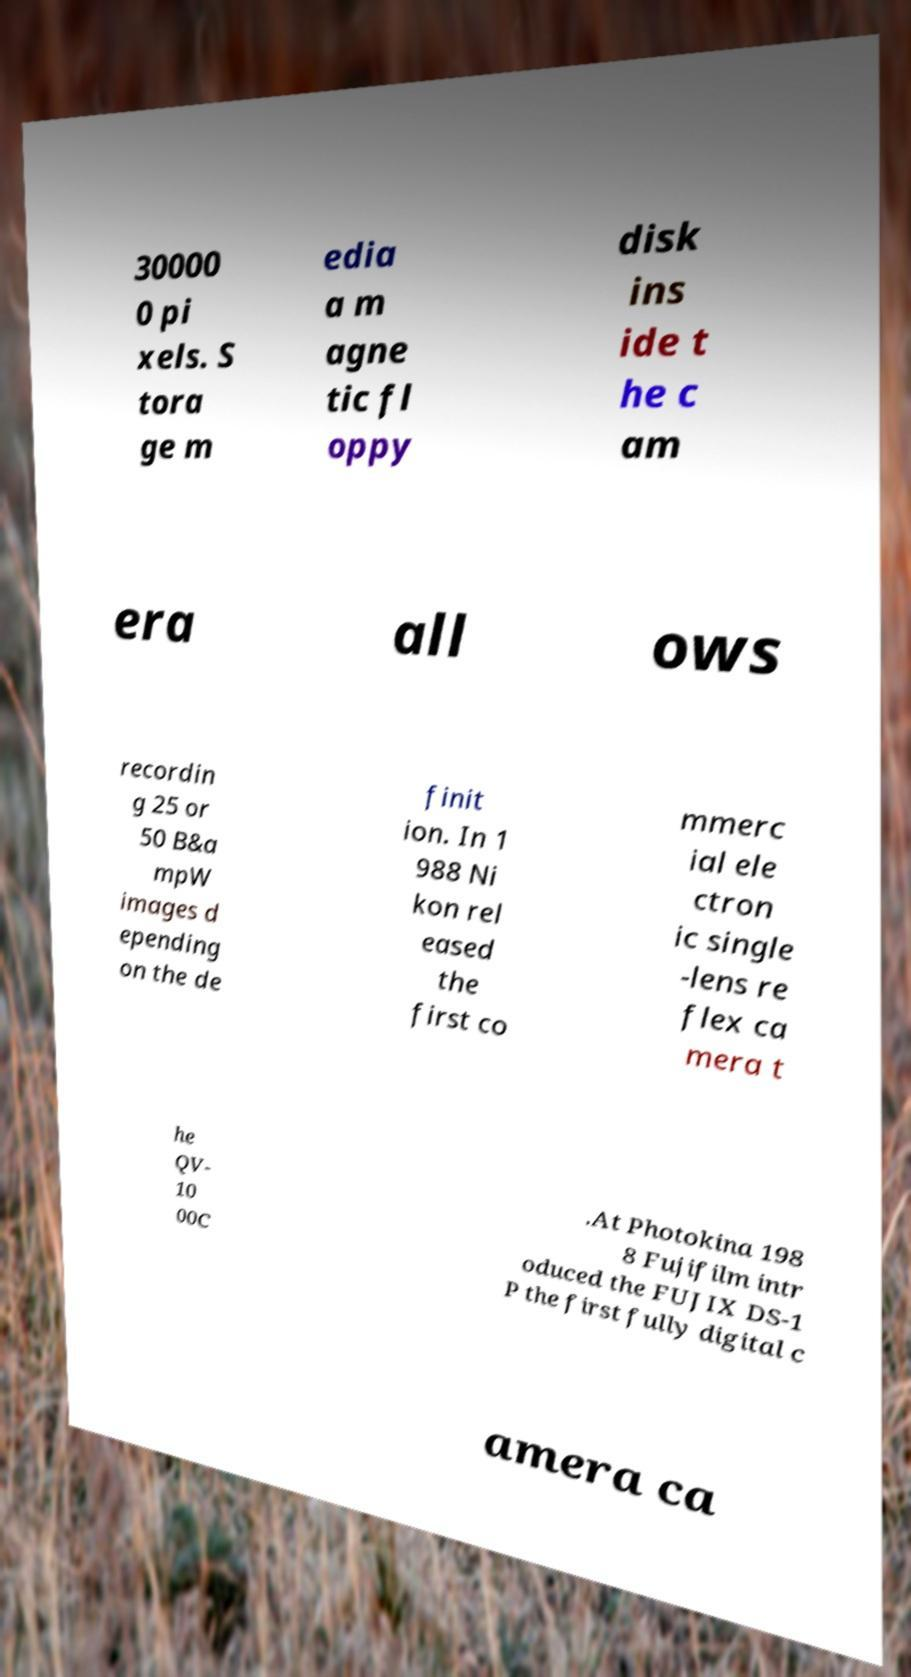For documentation purposes, I need the text within this image transcribed. Could you provide that? 30000 0 pi xels. S tora ge m edia a m agne tic fl oppy disk ins ide t he c am era all ows recordin g 25 or 50 B&a mpW images d epending on the de finit ion. In 1 988 Ni kon rel eased the first co mmerc ial ele ctron ic single -lens re flex ca mera t he QV- 10 00C .At Photokina 198 8 Fujifilm intr oduced the FUJIX DS-1 P the first fully digital c amera ca 